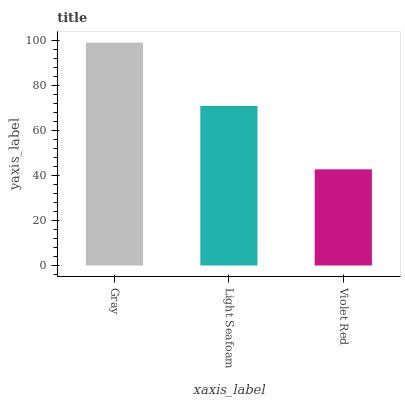Is Violet Red the minimum?
Answer yes or no. Yes. Is Gray the maximum?
Answer yes or no. Yes. Is Light Seafoam the minimum?
Answer yes or no. No. Is Light Seafoam the maximum?
Answer yes or no. No. Is Gray greater than Light Seafoam?
Answer yes or no. Yes. Is Light Seafoam less than Gray?
Answer yes or no. Yes. Is Light Seafoam greater than Gray?
Answer yes or no. No. Is Gray less than Light Seafoam?
Answer yes or no. No. Is Light Seafoam the high median?
Answer yes or no. Yes. Is Light Seafoam the low median?
Answer yes or no. Yes. Is Violet Red the high median?
Answer yes or no. No. Is Violet Red the low median?
Answer yes or no. No. 